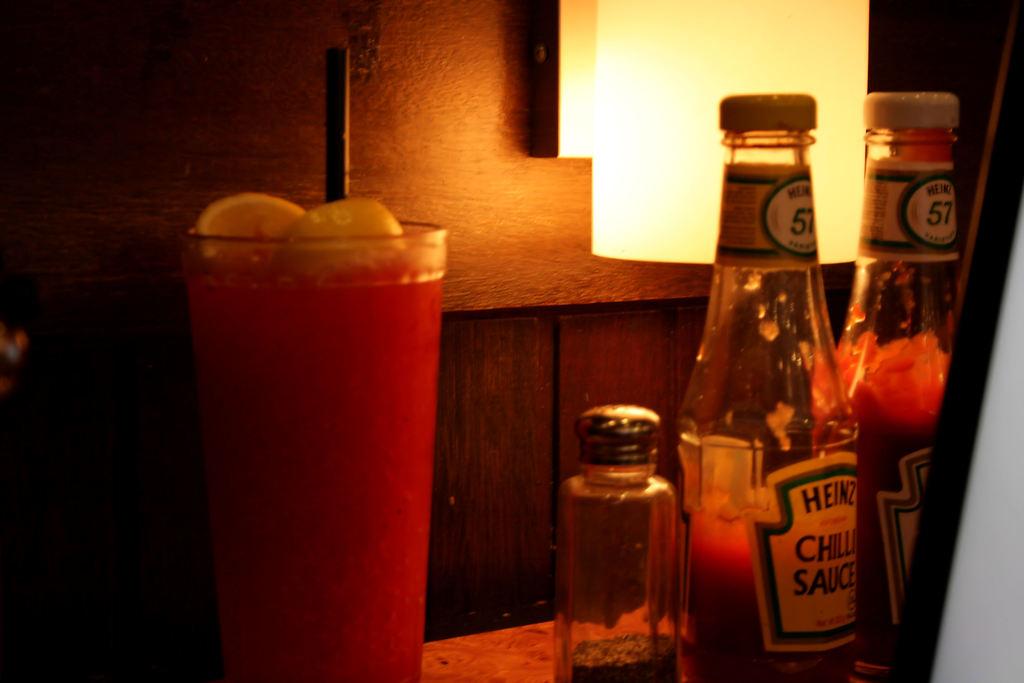What number is on the top labels of the bottles?
Offer a very short reply. 57. What kind of ketchup is it?
Ensure brevity in your answer.  Heinz. 